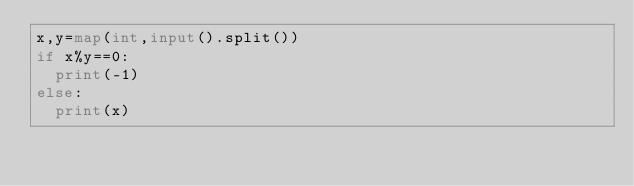Convert code to text. <code><loc_0><loc_0><loc_500><loc_500><_Python_>x,y=map(int,input().split())
if x%y==0:
	print(-1)
else:
	print(x)</code> 